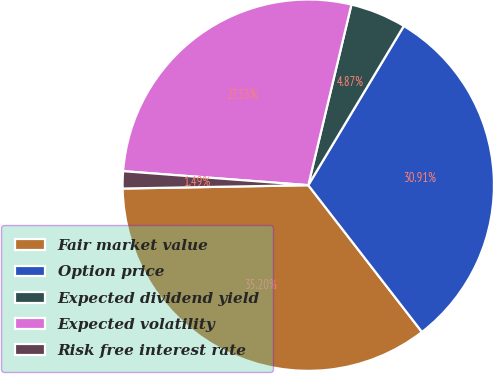<chart> <loc_0><loc_0><loc_500><loc_500><pie_chart><fcel>Fair market value<fcel>Option price<fcel>Expected dividend yield<fcel>Expected volatility<fcel>Risk free interest rate<nl><fcel>35.2%<fcel>30.91%<fcel>4.87%<fcel>27.53%<fcel>1.49%<nl></chart> 